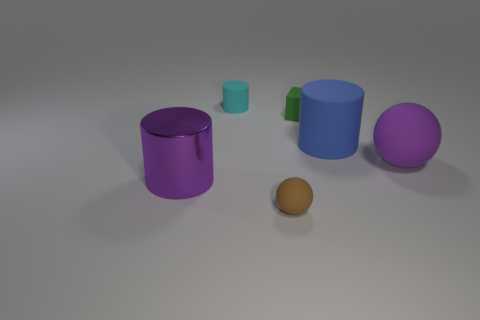Can you describe the lighting in the scene? The scene is softly lit from above, casting gentle shadows on the ground that suggest an overcast or diffused light source, creating a calm and evenly illuminated environment. 